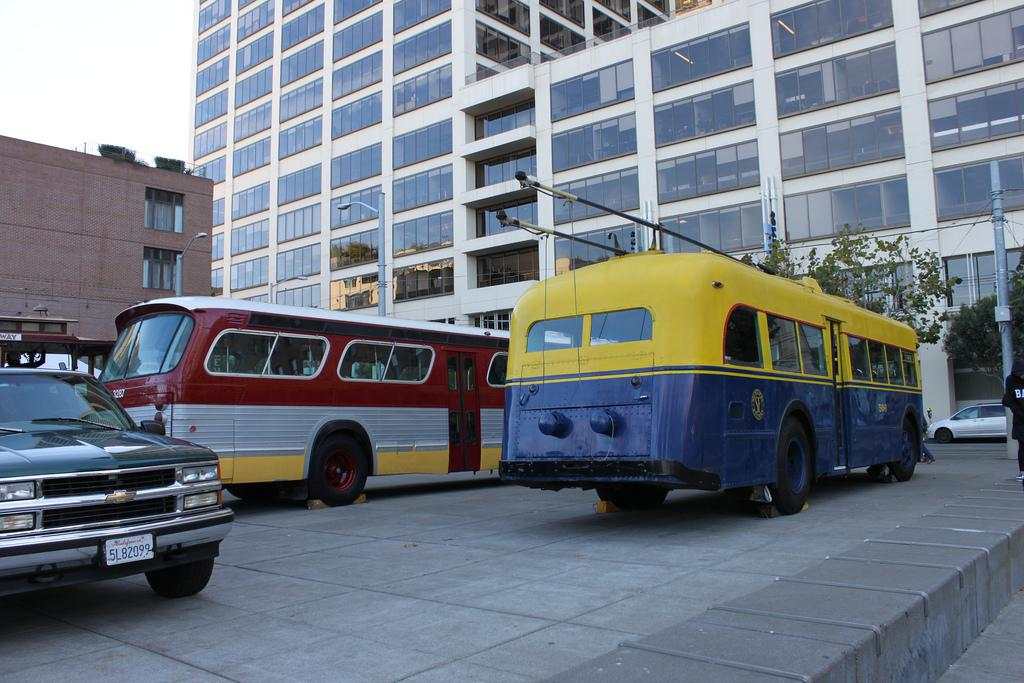Question: how many buses are in the picture?
Choices:
A. One.
B. Five.
C. Two.
D. Ten.
Answer with the letter. Answer: C Question: who parked the buses?
Choices:
A. A limo driver.
B. A truck driver.
C. Bus drivers.
D. The boy on skateboard.
Answer with the letter. Answer: C Question: what vehicle is to the left of the buses?
Choices:
A. A motorcycle.
B. A car.
C. A truck.
D. A moped.
Answer with the letter. Answer: C Question: when was this picture taken?
Choices:
A. Night time.
B. Day time.
C. Early morning.
D. Sunset.
Answer with the letter. Answer: B Question: where was picture taken?
Choices:
A. On the sidewalk.
B. At the bus stop.
C. At the train depot.
D. On a city street.
Answer with the letter. Answer: D Question: where was this picture taken?
Choices:
A. At airshow.
B. During the car show.
C. At a monster truck event.
D. Near buses.
Answer with the letter. Answer: D Question: where was the picture taken?
Choices:
A. In a city.
B. In London.
C. At a farm.
D. In the ZOO.
Answer with the letter. Answer: A Question: how is the truck parked in relation to the buses?
Choices:
A. Behind the buses.
B. In front of the buses.
C. Perpendicular.
D. Parallel to the buses.
Answer with the letter. Answer: C Question: what colors is the train on the right?
Choices:
A. Blue and yellow.
B. Red and black.
C. Red and grey.
D. Blue and grey.
Answer with the letter. Answer: A Question: what colour is the train on the left?
Choices:
A. Orange and black.
B. Green and brown.
C. Red, white, and yellow.
D. Silver and grey.
Answer with the letter. Answer: C Question: what is the ground made of?
Choices:
A. Cement and large tiles.
B. Asphalt.
C. Cobblestones.
D. Dirt.
Answer with the letter. Answer: A Question: what has many windows?
Choices:
A. A concert hall.
B. A greenhouse.
C. Large white building.
D. A skyscraper.
Answer with the letter. Answer: C Question: what is parked across from buses?
Choices:
A. A Red SUV.
B. An army jeep.
C. A black sedan.
D. Small white car.
Answer with the letter. Answer: D Question: where is brown building?
Choices:
A. To the right.
B. Straight ahead.
C. To left of buses.
D. Behind the cars.
Answer with the letter. Answer: C Question: where is a truck facing?
Choices:
A. North.
B. South.
C. East.
D. A different way than two buses.
Answer with the letter. Answer: D Question: what is parallel to each other?
Choices:
A. Cars.
B. Trees.
C. Boats.
D. Buses.
Answer with the letter. Answer: D Question: what is overcast?
Choices:
A. The sky.
B. The scene.
C. The birds.
D. The flies.
Answer with the letter. Answer: B Question: what kind of scene is it?
Choices:
A. Dark.
B. Clean.
C. Dirty.
D. Overcast.
Answer with the letter. Answer: D 